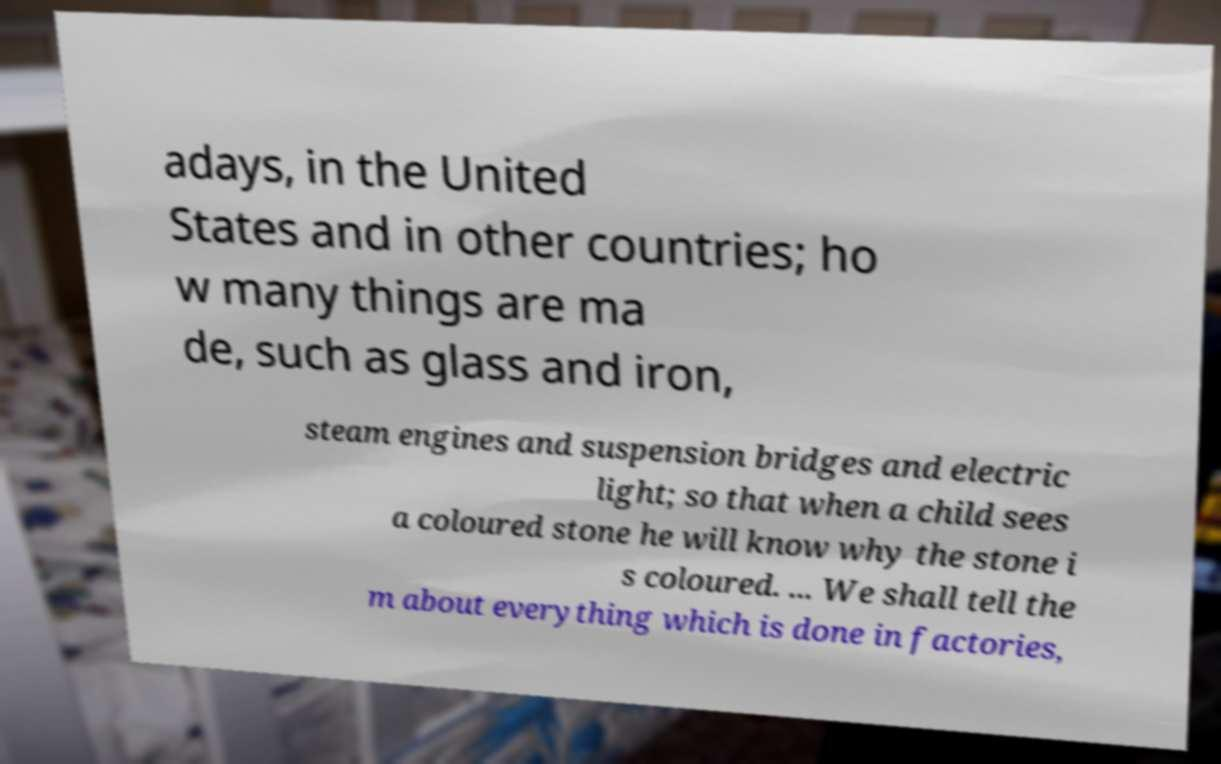I need the written content from this picture converted into text. Can you do that? adays, in the United States and in other countries; ho w many things are ma de, such as glass and iron, steam engines and suspension bridges and electric light; so that when a child sees a coloured stone he will know why the stone i s coloured. ... We shall tell the m about everything which is done in factories, 